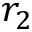Convert formula to latex. <formula><loc_0><loc_0><loc_500><loc_500>r _ { 2 }</formula> 